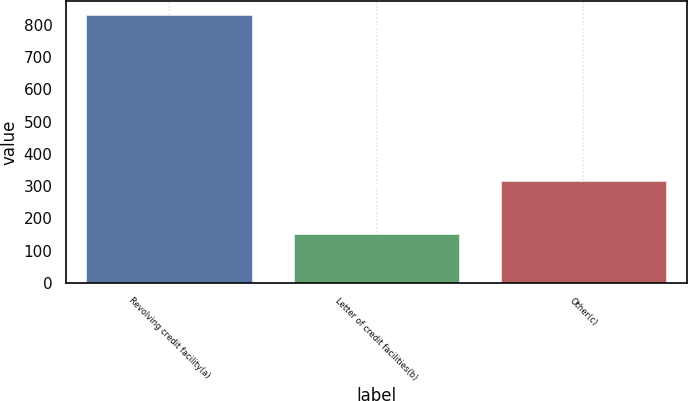<chart> <loc_0><loc_0><loc_500><loc_500><bar_chart><fcel>Revolving credit facility(a)<fcel>Letter of credit facilities(b)<fcel>Other(c)<nl><fcel>831<fcel>150<fcel>316<nl></chart> 